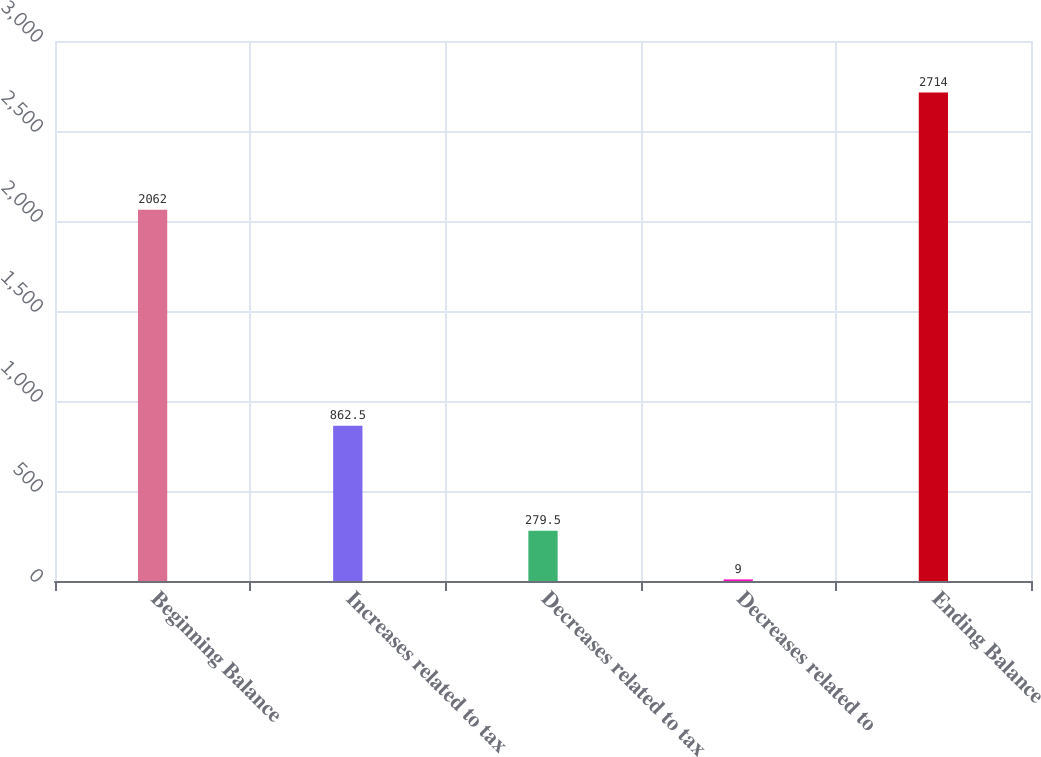<chart> <loc_0><loc_0><loc_500><loc_500><bar_chart><fcel>Beginning Balance<fcel>Increases related to tax<fcel>Decreases related to tax<fcel>Decreases related to<fcel>Ending Balance<nl><fcel>2062<fcel>862.5<fcel>279.5<fcel>9<fcel>2714<nl></chart> 